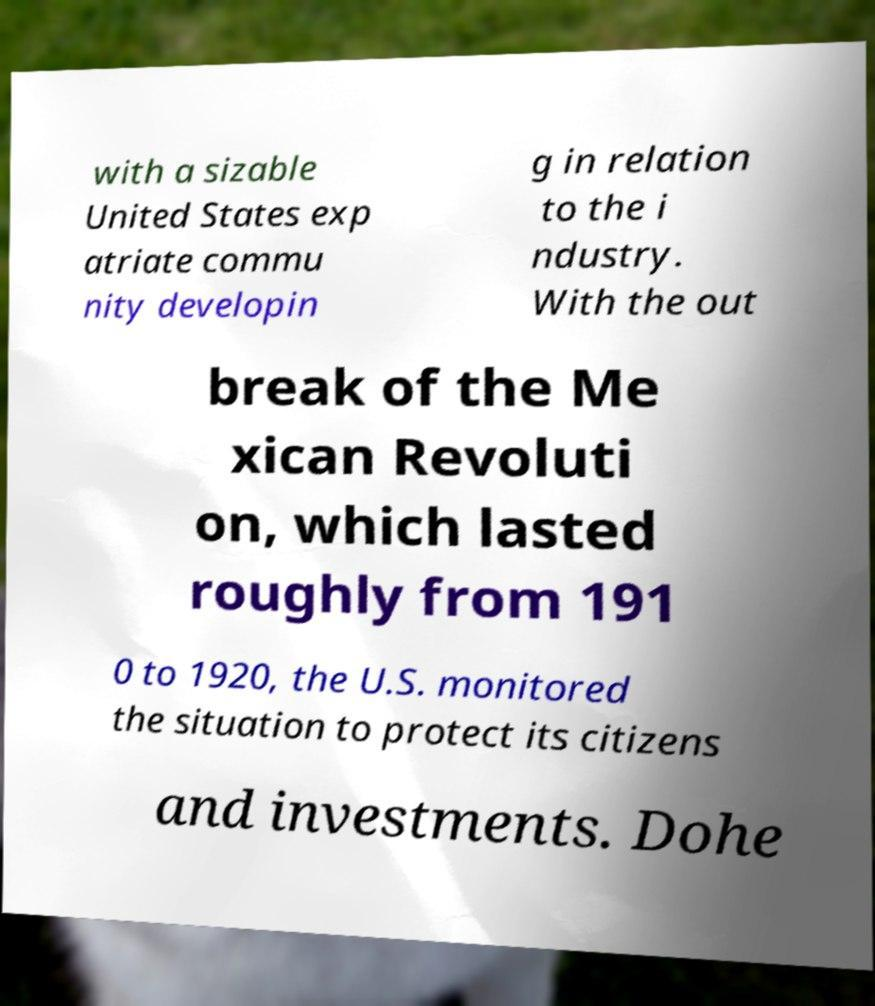Could you extract and type out the text from this image? with a sizable United States exp atriate commu nity developin g in relation to the i ndustry. With the out break of the Me xican Revoluti on, which lasted roughly from 191 0 to 1920, the U.S. monitored the situation to protect its citizens and investments. Dohe 